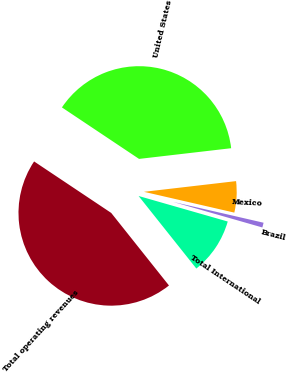<chart> <loc_0><loc_0><loc_500><loc_500><pie_chart><fcel>United States<fcel>Mexico<fcel>Brazil<fcel>Total International<fcel>Total operating revenues<nl><fcel>38.79%<fcel>5.44%<fcel>0.84%<fcel>9.86%<fcel>45.07%<nl></chart> 